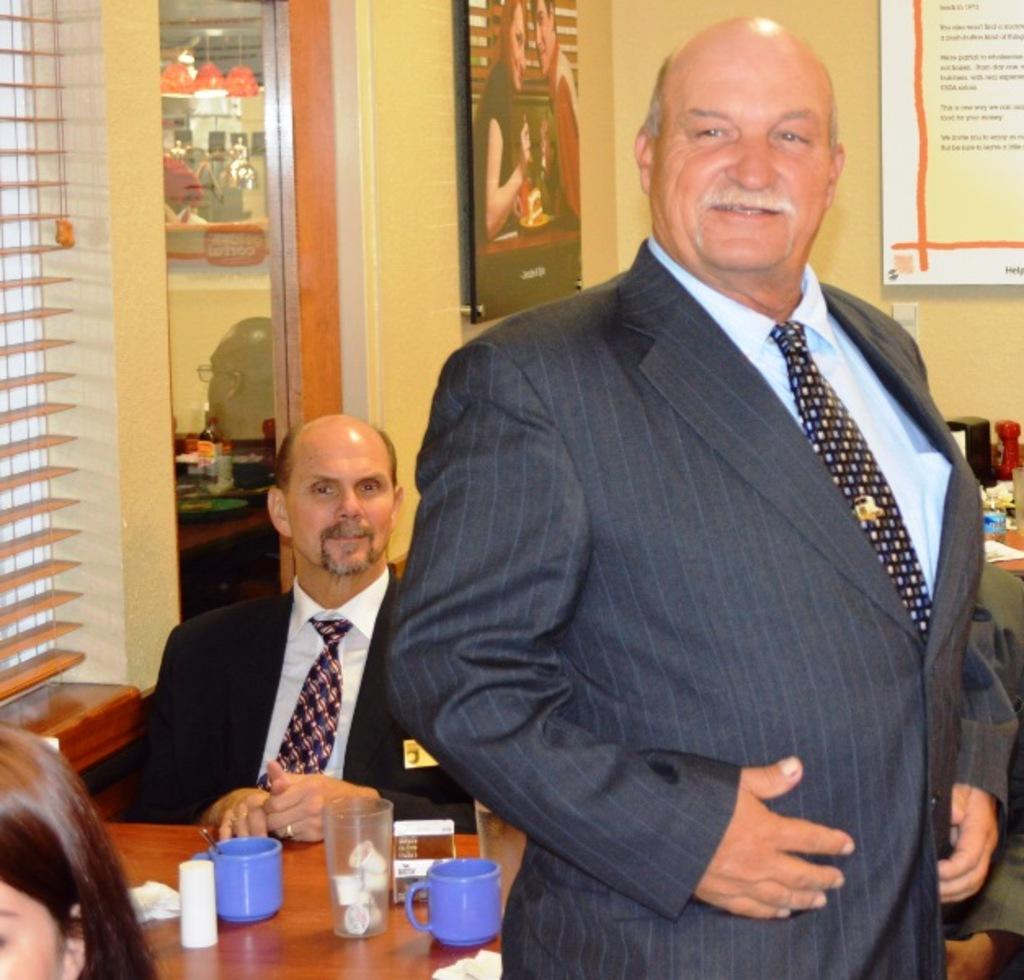How many persons are in the image? There are persons in the image. What is made of glass in the image? There is glass in the image. What type of container is present in the image? There are cups in the image. What can be seen in the background of the image? There is a window, a wall, frames, and other objects in the background of the image. What type of slave is depicted in the image? There is no depiction of a slave in the image. What system is being used to control the persons in the image? There is no system controlling the persons in the image; they are simply present. 